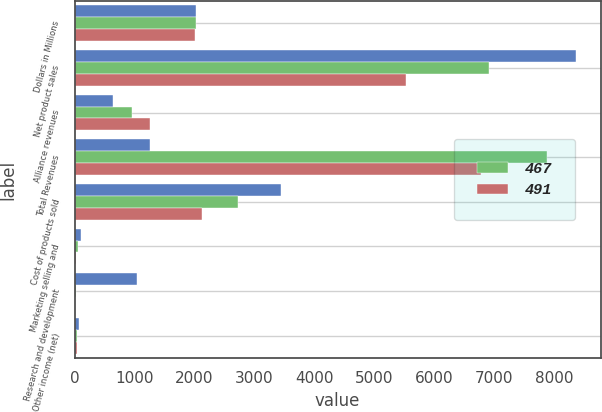<chart> <loc_0><loc_0><loc_500><loc_500><stacked_bar_chart><ecel><fcel>Dollars in Millions<fcel>Net product sales<fcel>Alliance revenues<fcel>Total Revenues<fcel>Cost of products sold<fcel>Marketing selling and<fcel>Research and development<fcel>Other income (net)<nl><fcel>nan<fcel>2018<fcel>8359<fcel>647<fcel>1252<fcel>3439<fcel>104<fcel>1044<fcel>67<nl><fcel>467<fcel>2017<fcel>6917<fcel>962<fcel>7879<fcel>2718<fcel>62<fcel>28<fcel>46<nl><fcel>491<fcel>2016<fcel>5530<fcel>1252<fcel>6782<fcel>2126<fcel>30<fcel>9<fcel>42<nl></chart> 